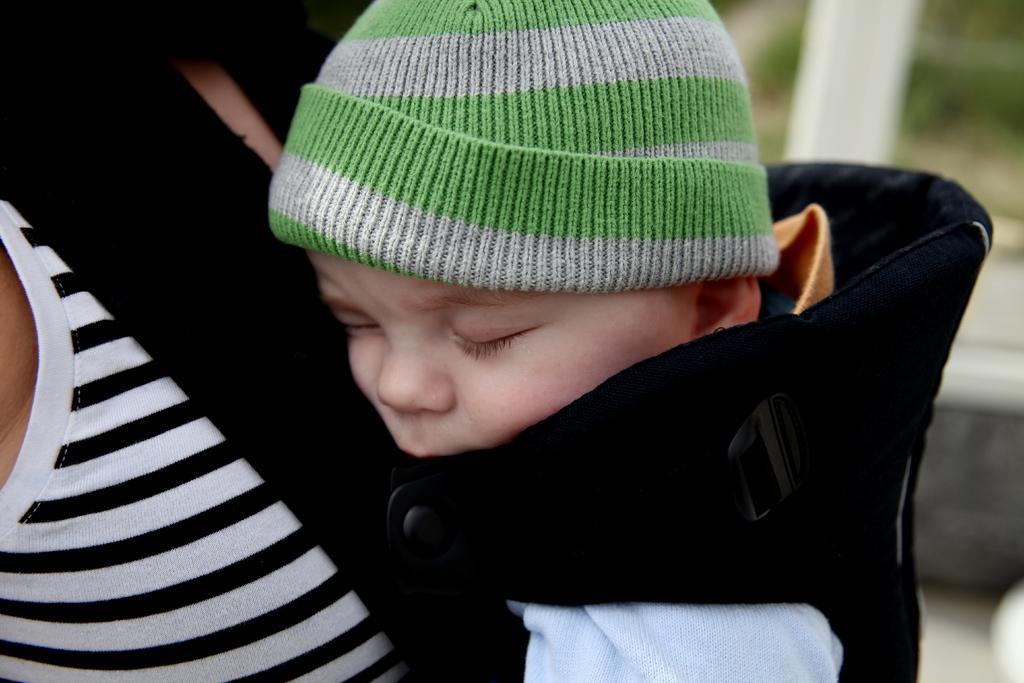Please provide a concise description of this image. In this picture we can see a baby in a baby carrier resting on a woman. 